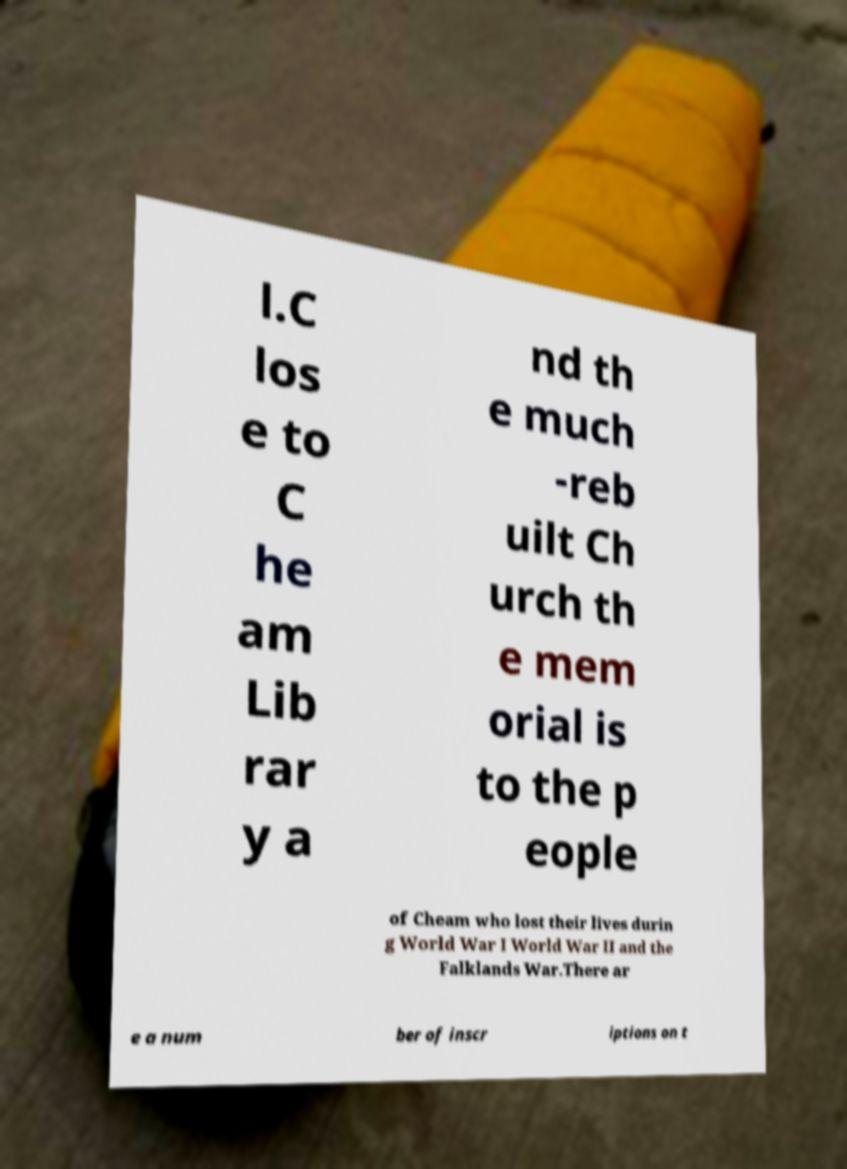For documentation purposes, I need the text within this image transcribed. Could you provide that? l.C los e to C he am Lib rar y a nd th e much -reb uilt Ch urch th e mem orial is to the p eople of Cheam who lost their lives durin g World War I World War II and the Falklands War.There ar e a num ber of inscr iptions on t 